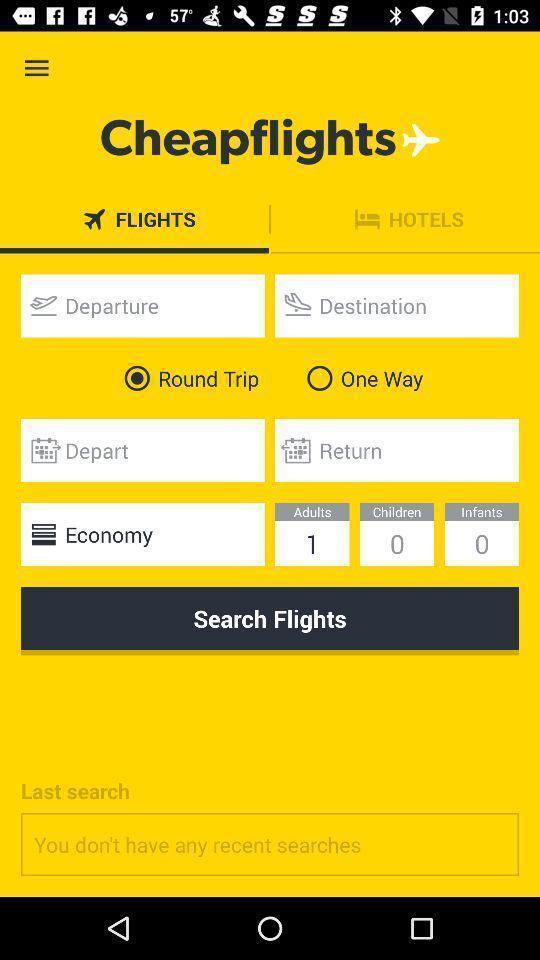Explain what's happening in this screen capture. Screen displaying the page of a flight booking app. 